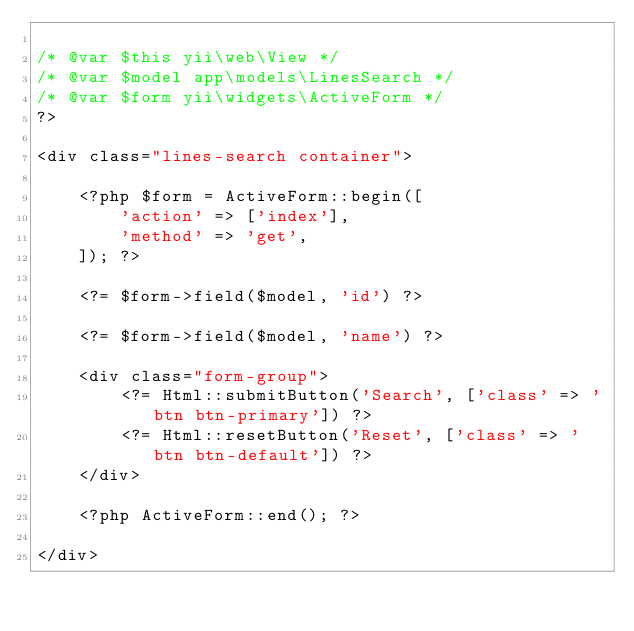Convert code to text. <code><loc_0><loc_0><loc_500><loc_500><_PHP_>
/* @var $this yii\web\View */
/* @var $model app\models\LinesSearch */
/* @var $form yii\widgets\ActiveForm */
?>

<div class="lines-search container">

    <?php $form = ActiveForm::begin([
        'action' => ['index'],
        'method' => 'get',
    ]); ?>

    <?= $form->field($model, 'id') ?>

    <?= $form->field($model, 'name') ?>

    <div class="form-group">
        <?= Html::submitButton('Search', ['class' => 'btn btn-primary']) ?>
        <?= Html::resetButton('Reset', ['class' => 'btn btn-default']) ?>
    </div>

    <?php ActiveForm::end(); ?>

</div>
</code> 